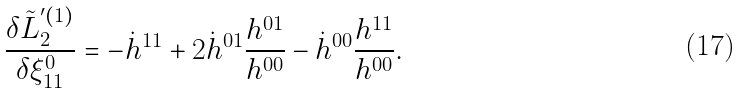<formula> <loc_0><loc_0><loc_500><loc_500>\frac { \delta \tilde { L } _ { 2 } ^ { ^ { \prime } ( 1 ) } } { \delta \xi _ { 1 1 } ^ { 0 } } = - \dot { h } ^ { 1 1 } + 2 \dot { h } ^ { 0 1 } \frac { h ^ { 0 1 } } { h ^ { 0 0 } } - \dot { h } ^ { 0 0 } \frac { h ^ { 1 1 } } { h ^ { 0 0 } } .</formula> 